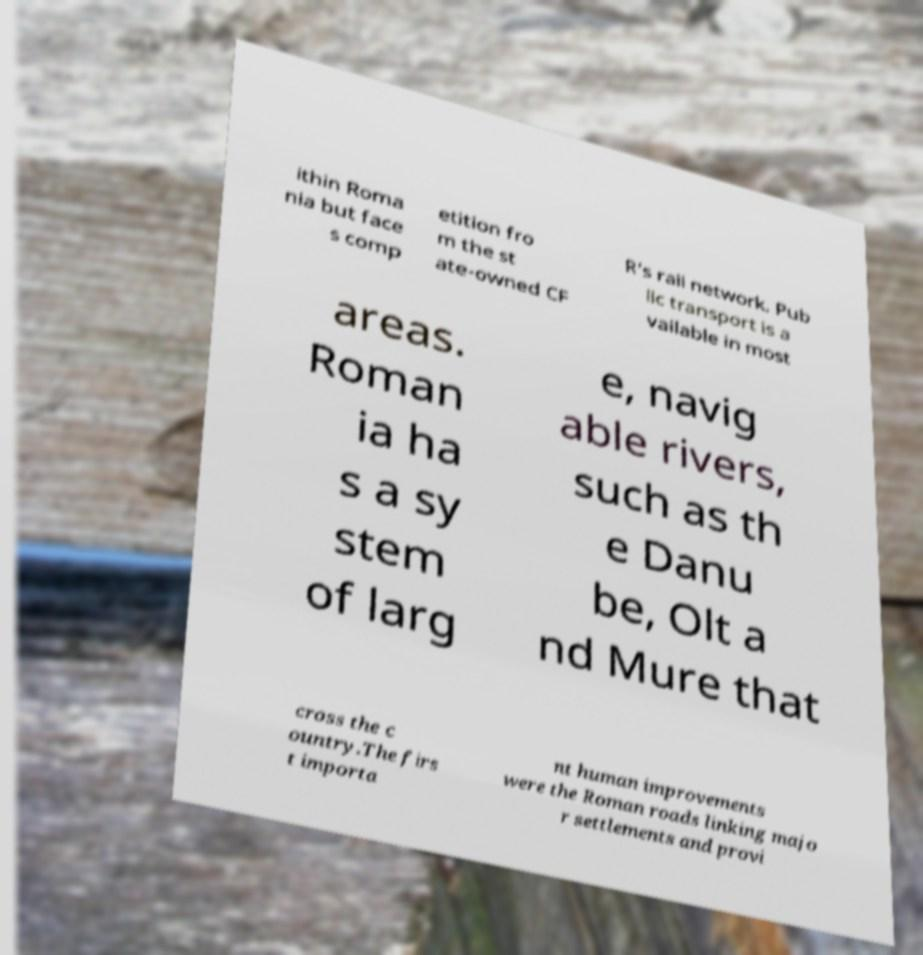For documentation purposes, I need the text within this image transcribed. Could you provide that? ithin Roma nia but face s comp etition fro m the st ate-owned CF R's rail network. Pub lic transport is a vailable in most areas. Roman ia ha s a sy stem of larg e, navig able rivers, such as th e Danu be, Olt a nd Mure that cross the c ountry.The firs t importa nt human improvements were the Roman roads linking majo r settlements and provi 